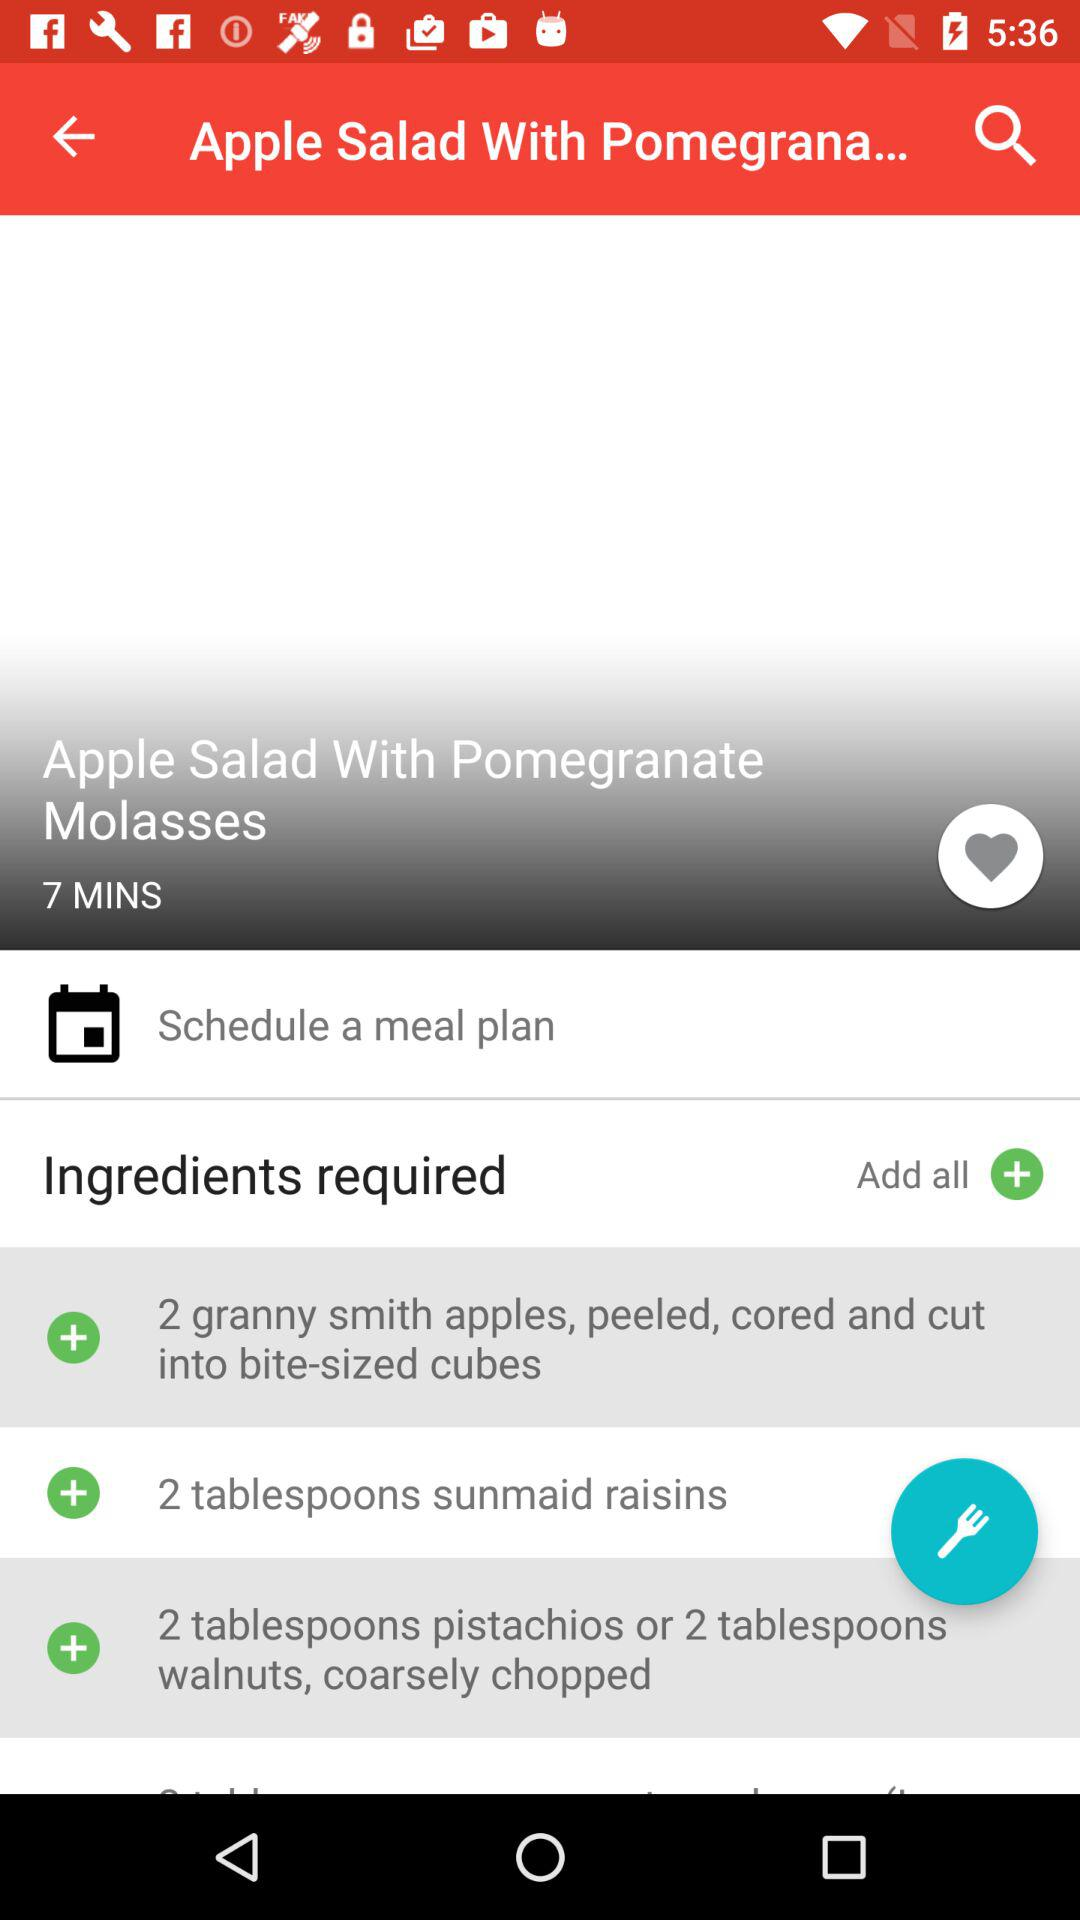Which chopped items are required? The required chopped item is either pistachios or walnuts. 